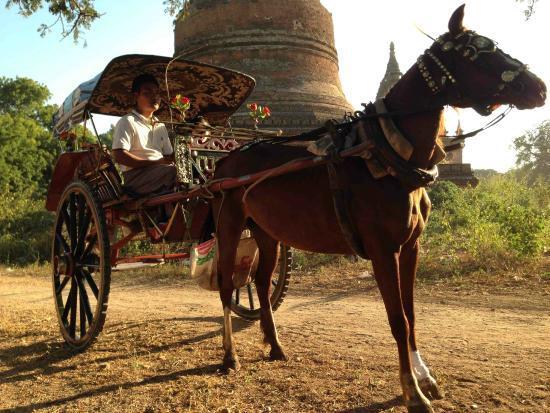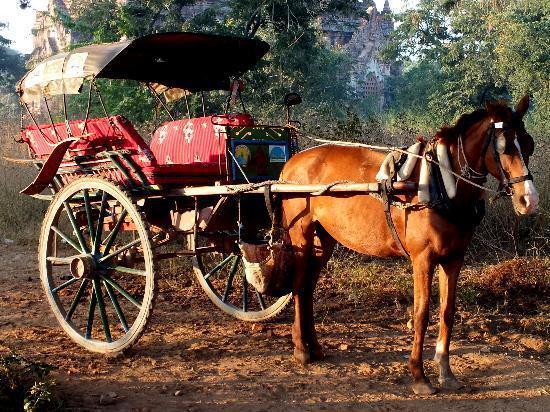The first image is the image on the left, the second image is the image on the right. Examine the images to the left and right. Is the description "The right image shows a passenger in a two-wheeled horse-drawn cart, and the left image shows a passenger-less two-wheeled cart hitched to a horse." accurate? Answer yes or no. No. The first image is the image on the left, the second image is the image on the right. For the images shown, is this caption "The left and right image contains the same number of horses pulling a cart in different directions." true? Answer yes or no. No. 